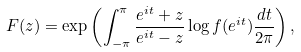<formula> <loc_0><loc_0><loc_500><loc_500>F ( z ) = \exp \left ( \int _ { - \pi } ^ { \pi } \frac { e ^ { i t } + z } { e ^ { i t } - z } \log f ( e ^ { i t } ) \frac { d t } { 2 \pi } \right ) ,</formula> 